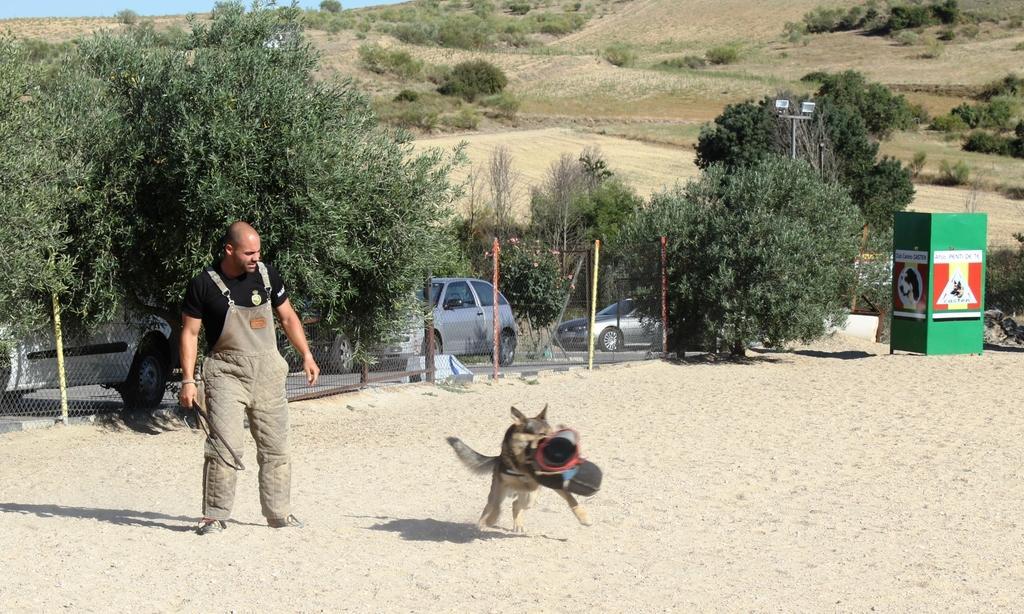In one or two sentences, can you explain what this image depicts? This is an outside view. In the middle of the image there is a dog holding an object in the mouth. On the left side there is a man standing and looking at the dog. In the background there are many trees and cars on the road. On the left side there is a net fencing at the back of this man. On the right side there is a green color box which is placed on the ground. 